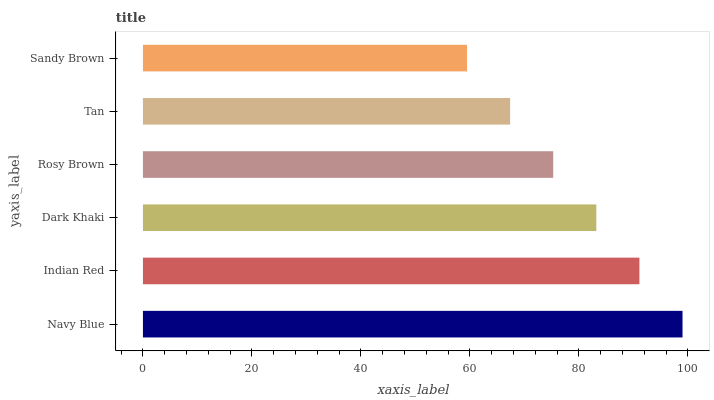Is Sandy Brown the minimum?
Answer yes or no. Yes. Is Navy Blue the maximum?
Answer yes or no. Yes. Is Indian Red the minimum?
Answer yes or no. No. Is Indian Red the maximum?
Answer yes or no. No. Is Navy Blue greater than Indian Red?
Answer yes or no. Yes. Is Indian Red less than Navy Blue?
Answer yes or no. Yes. Is Indian Red greater than Navy Blue?
Answer yes or no. No. Is Navy Blue less than Indian Red?
Answer yes or no. No. Is Dark Khaki the high median?
Answer yes or no. Yes. Is Rosy Brown the low median?
Answer yes or no. Yes. Is Tan the high median?
Answer yes or no. No. Is Navy Blue the low median?
Answer yes or no. No. 